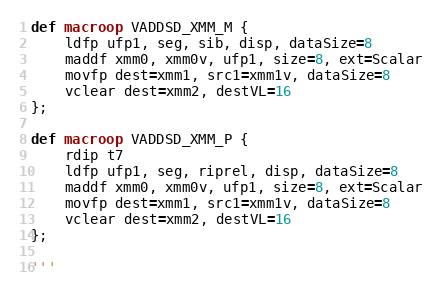Convert code to text. <code><loc_0><loc_0><loc_500><loc_500><_Python_>
def macroop VADDSD_XMM_M {
    ldfp ufp1, seg, sib, disp, dataSize=8
    maddf xmm0, xmm0v, ufp1, size=8, ext=Scalar
    movfp dest=xmm1, src1=xmm1v, dataSize=8
    vclear dest=xmm2, destVL=16
};

def macroop VADDSD_XMM_P {
    rdip t7
    ldfp ufp1, seg, riprel, disp, dataSize=8
    maddf xmm0, xmm0v, ufp1, size=8, ext=Scalar
    movfp dest=xmm1, src1=xmm1v, dataSize=8
    vclear dest=xmm2, destVL=16
};

'''
</code> 